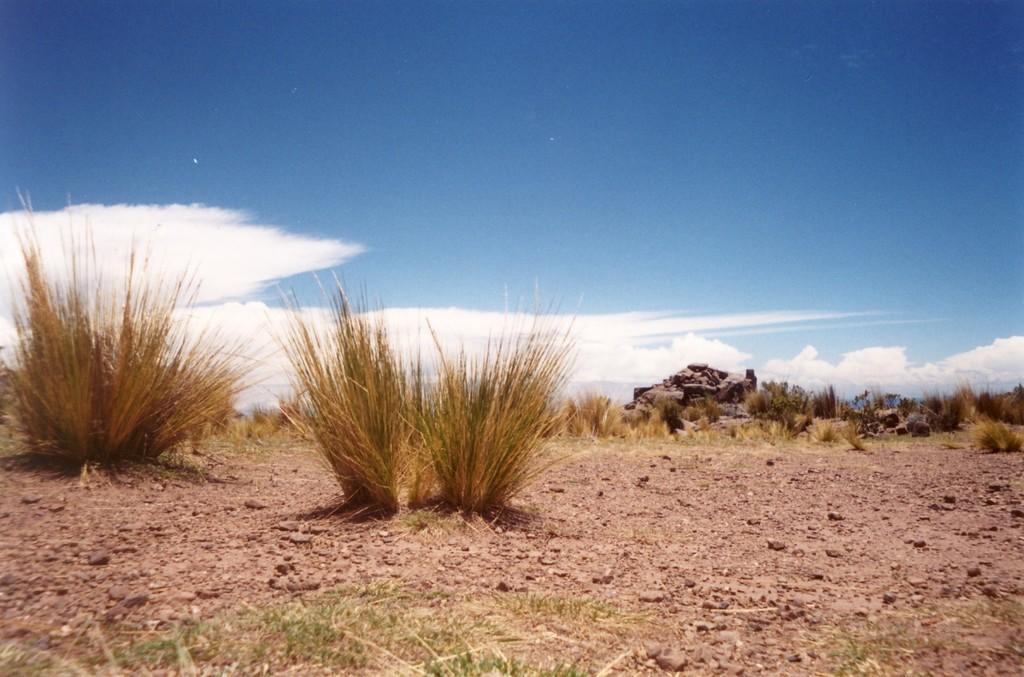In one or two sentences, can you explain what this image depicts? In this image we can see ground, grass, and stones. In the background there is sky with clouds. 